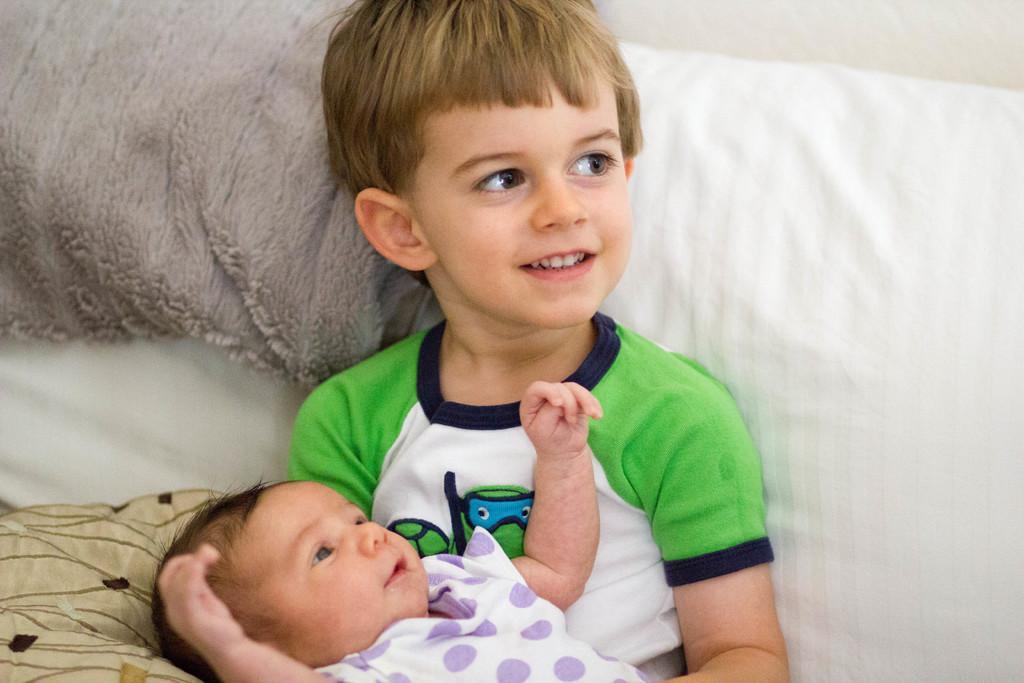Can you describe this image briefly? In this image I can see a boy in green t shirt and a baby in white dress. I can also see smile on his face. 